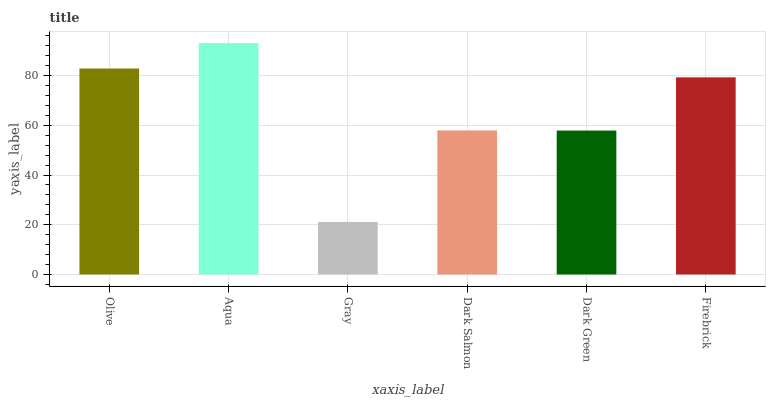Is Aqua the minimum?
Answer yes or no. No. Is Gray the maximum?
Answer yes or no. No. Is Aqua greater than Gray?
Answer yes or no. Yes. Is Gray less than Aqua?
Answer yes or no. Yes. Is Gray greater than Aqua?
Answer yes or no. No. Is Aqua less than Gray?
Answer yes or no. No. Is Firebrick the high median?
Answer yes or no. Yes. Is Dark Salmon the low median?
Answer yes or no. Yes. Is Dark Salmon the high median?
Answer yes or no. No. Is Olive the low median?
Answer yes or no. No. 